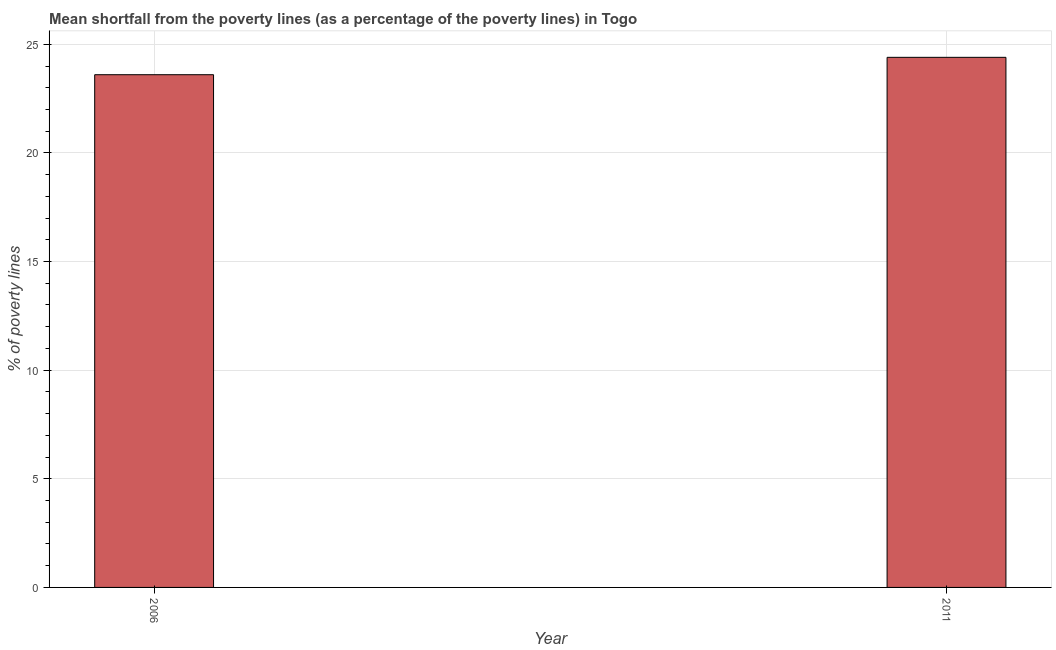What is the title of the graph?
Your response must be concise. Mean shortfall from the poverty lines (as a percentage of the poverty lines) in Togo. What is the label or title of the Y-axis?
Provide a succinct answer. % of poverty lines. What is the poverty gap at national poverty lines in 2006?
Ensure brevity in your answer.  23.6. Across all years, what is the maximum poverty gap at national poverty lines?
Keep it short and to the point. 24.4. Across all years, what is the minimum poverty gap at national poverty lines?
Provide a succinct answer. 23.6. What is the sum of the poverty gap at national poverty lines?
Make the answer very short. 48. What is the difference between the poverty gap at national poverty lines in 2006 and 2011?
Offer a terse response. -0.8. Do a majority of the years between 2011 and 2006 (inclusive) have poverty gap at national poverty lines greater than 24 %?
Keep it short and to the point. No. What is the ratio of the poverty gap at national poverty lines in 2006 to that in 2011?
Your answer should be very brief. 0.97. Is the poverty gap at national poverty lines in 2006 less than that in 2011?
Make the answer very short. Yes. In how many years, is the poverty gap at national poverty lines greater than the average poverty gap at national poverty lines taken over all years?
Provide a succinct answer. 1. How many years are there in the graph?
Your response must be concise. 2. Are the values on the major ticks of Y-axis written in scientific E-notation?
Your answer should be very brief. No. What is the % of poverty lines of 2006?
Your answer should be very brief. 23.6. What is the % of poverty lines in 2011?
Provide a succinct answer. 24.4. What is the ratio of the % of poverty lines in 2006 to that in 2011?
Your answer should be compact. 0.97. 